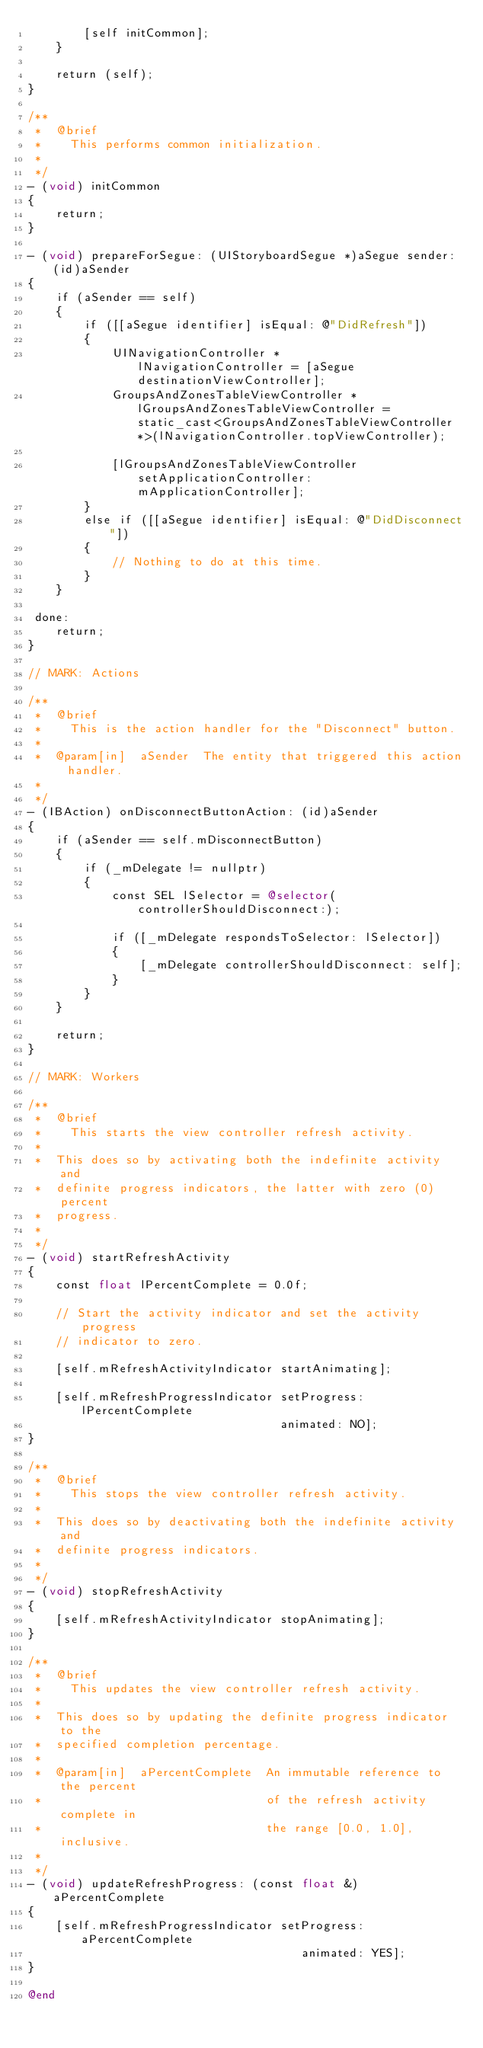Convert code to text. <code><loc_0><loc_0><loc_500><loc_500><_ObjectiveC_>        [self initCommon];
    }

    return (self);
}

/**
 *  @brief
 *    This performs common initialization.
 *
 */
- (void) initCommon
{
    return;
}

- (void) prepareForSegue: (UIStoryboardSegue *)aSegue sender: (id)aSender
{
    if (aSender == self)
    {
        if ([[aSegue identifier] isEqual: @"DidRefresh"])
        {
            UINavigationController *             lNavigationController = [aSegue destinationViewController];
            GroupsAndZonesTableViewController *  lGroupsAndZonesTableViewController = static_cast<GroupsAndZonesTableViewController *>(lNavigationController.topViewController);

            [lGroupsAndZonesTableViewController setApplicationController: mApplicationController];
        }
        else if ([[aSegue identifier] isEqual: @"DidDisconnect"])
        {
            // Nothing to do at this time.
        }
    }

 done:
    return;
}

// MARK: Actions

/**
 *  @brief
 *    This is the action handler for the "Disconnect" button.
 *
 *  @param[in]  aSender  The entity that triggered this action handler.
 *
 */
- (IBAction) onDisconnectButtonAction: (id)aSender
{
    if (aSender == self.mDisconnectButton)
    {
        if (_mDelegate != nullptr)
        {
            const SEL lSelector = @selector(controllerShouldDisconnect:);

            if ([_mDelegate respondsToSelector: lSelector])
            {
                [_mDelegate controllerShouldDisconnect: self];
            }
        }
    }

    return;
}

// MARK: Workers

/**
 *  @brief
 *    This starts the view controller refresh activity.
 *
 *  This does so by activating both the indefinite activity and
 *  definite progress indicators, the latter with zero (0) percent
 *  progress.
 *
 */
- (void) startRefreshActivity
{
    const float lPercentComplete = 0.0f;

    // Start the activity indicator and set the activity progress
    // indicator to zero.

    [self.mRefreshActivityIndicator startAnimating];

    [self.mRefreshProgressIndicator setProgress: lPercentComplete
                                    animated: NO];
}

/**
 *  @brief
 *    This stops the view controller refresh activity.
 *
 *  This does so by deactivating both the indefinite activity and
 *  definite progress indicators.
 *
 */
- (void) stopRefreshActivity
{
    [self.mRefreshActivityIndicator stopAnimating];
}

/**
 *  @brief
 *    This updates the view controller refresh activity.
 *
 *  This does so by updating the definite progress indicator to the
 *  specified completion percentage.
 *
 *  @param[in]  aPercentComplete  An immutable reference to the percent
 *                                of the refresh activity complete in
 *                                the range [0.0, 1.0], inclusive.
 *
 */
- (void) updateRefreshProgress: (const float &)aPercentComplete
{
    [self.mRefreshProgressIndicator setProgress: aPercentComplete
                                       animated: YES];
}

@end
</code> 